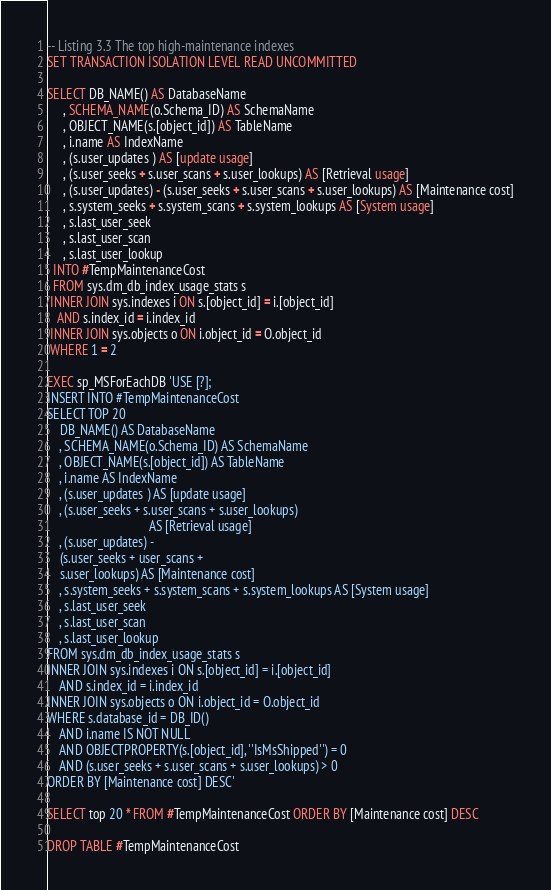<code> <loc_0><loc_0><loc_500><loc_500><_SQL_>-- Listing 3.3 The top high-maintenance indexes
SET TRANSACTION ISOLATION LEVEL READ UNCOMMITTED

SELECT DB_NAME() AS DatabaseName
     , SCHEMA_NAME(o.Schema_ID) AS SchemaName
     , OBJECT_NAME(s.[object_id]) AS TableName
     , i.name AS IndexName
     , (s.user_updates ) AS [update usage]
     , (s.user_seeks + s.user_scans + s.user_lookups) AS [Retrieval usage]
     , (s.user_updates) - (s.user_seeks + s.user_scans + s.user_lookups) AS [Maintenance cost]
     , s.system_seeks + s.system_scans + s.system_lookups AS [System usage]
     , s.last_user_seek
     , s.last_user_scan
     , s.last_user_lookup
  INTO #TempMaintenanceCost
  FROM sys.dm_db_index_usage_stats s
 INNER JOIN sys.indexes i ON s.[object_id] = i.[object_id]
   AND s.index_id = i.index_id
 INNER JOIN sys.objects o ON i.object_id = O.object_id
 WHERE 1 = 2

EXEC sp_MSForEachDB 'USE [?];
INSERT INTO #TempMaintenanceCost
SELECT TOP 20
	DB_NAME() AS DatabaseName
	, SCHEMA_NAME(o.Schema_ID) AS SchemaName
	, OBJECT_NAME(s.[object_id]) AS TableName
	, i.name AS IndexName
	, (s.user_updates ) AS [update usage]
	, (s.user_seeks + s.user_scans + s.user_lookups)
								AS [Retrieval usage]
	, (s.user_updates) -
	(s.user_seeks + user_scans +
	s.user_lookups) AS [Maintenance cost]
	, s.system_seeks + s.system_scans + s.system_lookups AS [System usage]
	, s.last_user_seek
	, s.last_user_scan
	, s.last_user_lookup
FROM sys.dm_db_index_usage_stats s
INNER JOIN sys.indexes i ON s.[object_id] = i.[object_id]
	AND s.index_id = i.index_id
INNER JOIN sys.objects o ON i.object_id = O.object_id
WHERE s.database_id = DB_ID()
	AND i.name IS NOT NULL
	AND OBJECTPROPERTY(s.[object_id], ''IsMsShipped'') = 0
	AND (s.user_seeks + s.user_scans + s.user_lookups) > 0
ORDER BY [Maintenance cost] DESC'

SELECT top 20 * FROM #TempMaintenanceCost ORDER BY [Maintenance cost] DESC

DROP TABLE #TempMaintenanceCost
</code> 